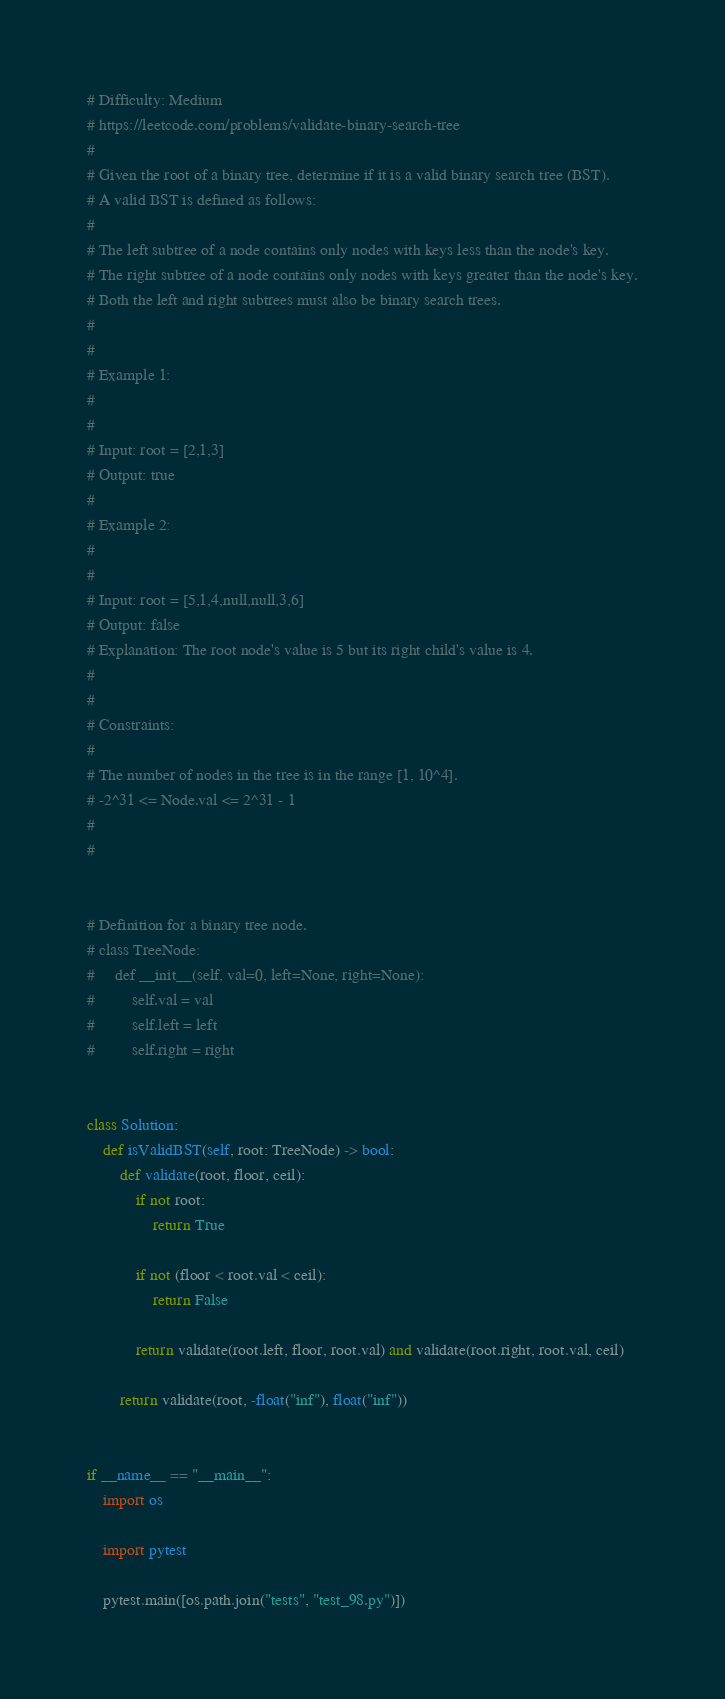<code> <loc_0><loc_0><loc_500><loc_500><_Python_># Difficulty: Medium
# https://leetcode.com/problems/validate-binary-search-tree
#
# Given the root of a binary tree, determine if it is a valid binary search tree (BST).
# A valid BST is defined as follows:
#
# The left subtree of a node contains only nodes with keys less than the node's key.
# The right subtree of a node contains only nodes with keys greater than the node's key.
# Both the left and right subtrees must also be binary search trees.
#
#
# Example 1:
#
#
# Input: root = [2,1,3]
# Output: true
#
# Example 2:
#
#
# Input: root = [5,1,4,null,null,3,6]
# Output: false
# Explanation: The root node's value is 5 but its right child's value is 4.
#
#
# Constraints:
#
# The number of nodes in the tree is in the range [1, 10^4].
# -2^31 <= Node.val <= 2^31 - 1
#
#


# Definition for a binary tree node.
# class TreeNode:
#     def __init__(self, val=0, left=None, right=None):
#         self.val = val
#         self.left = left
#         self.right = right


class Solution:
    def isValidBST(self, root: TreeNode) -> bool:
        def validate(root, floor, ceil):
            if not root:
                return True

            if not (floor < root.val < ceil):
                return False

            return validate(root.left, floor, root.val) and validate(root.right, root.val, ceil)

        return validate(root, -float("inf"), float("inf"))


if __name__ == "__main__":
    import os

    import pytest

    pytest.main([os.path.join("tests", "test_98.py")])
</code> 